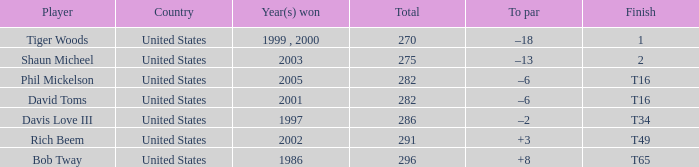What is Davis Love III's total? 286.0. 